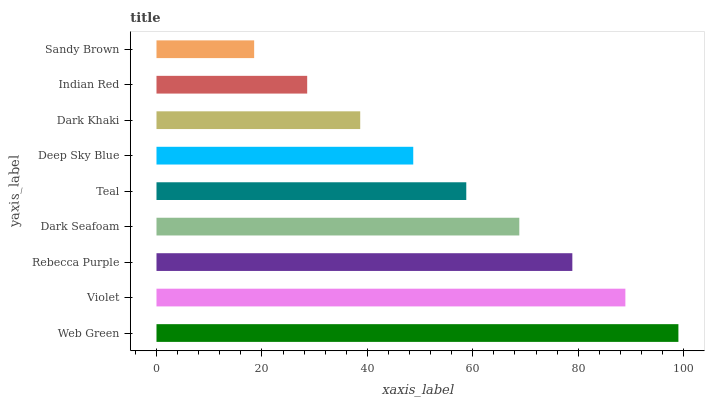Is Sandy Brown the minimum?
Answer yes or no. Yes. Is Web Green the maximum?
Answer yes or no. Yes. Is Violet the minimum?
Answer yes or no. No. Is Violet the maximum?
Answer yes or no. No. Is Web Green greater than Violet?
Answer yes or no. Yes. Is Violet less than Web Green?
Answer yes or no. Yes. Is Violet greater than Web Green?
Answer yes or no. No. Is Web Green less than Violet?
Answer yes or no. No. Is Teal the high median?
Answer yes or no. Yes. Is Teal the low median?
Answer yes or no. Yes. Is Rebecca Purple the high median?
Answer yes or no. No. Is Rebecca Purple the low median?
Answer yes or no. No. 